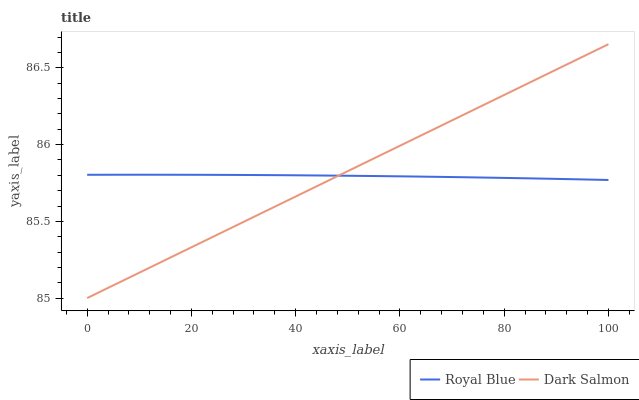Does Royal Blue have the minimum area under the curve?
Answer yes or no. Yes. Does Dark Salmon have the maximum area under the curve?
Answer yes or no. Yes. Does Dark Salmon have the minimum area under the curve?
Answer yes or no. No. Is Dark Salmon the smoothest?
Answer yes or no. Yes. Is Royal Blue the roughest?
Answer yes or no. Yes. Is Dark Salmon the roughest?
Answer yes or no. No. Does Dark Salmon have the lowest value?
Answer yes or no. Yes. Does Dark Salmon have the highest value?
Answer yes or no. Yes. Does Dark Salmon intersect Royal Blue?
Answer yes or no. Yes. Is Dark Salmon less than Royal Blue?
Answer yes or no. No. Is Dark Salmon greater than Royal Blue?
Answer yes or no. No. 